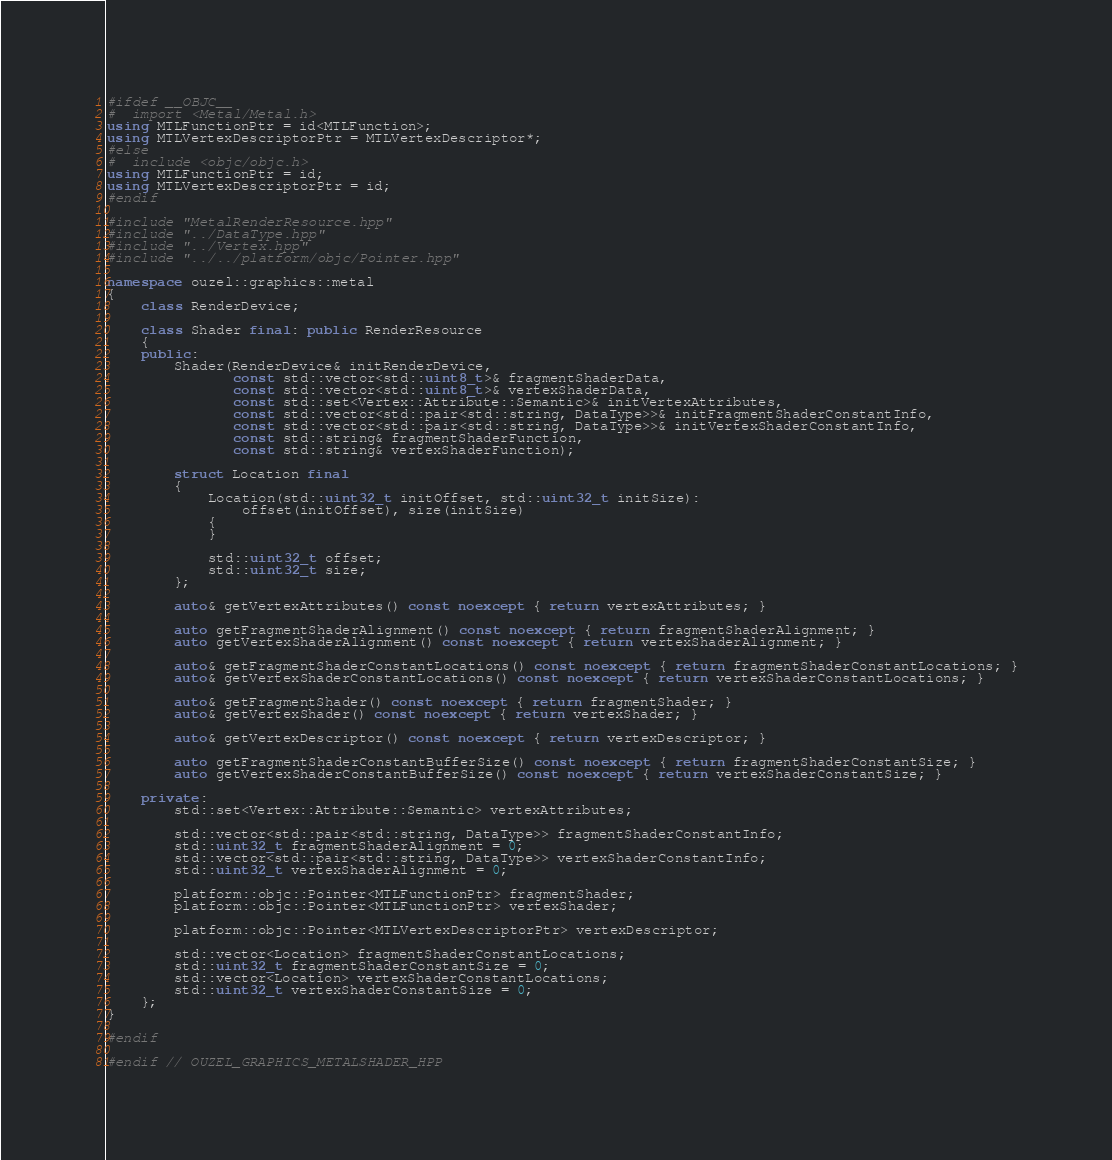<code> <loc_0><loc_0><loc_500><loc_500><_C++_>
#ifdef __OBJC__
#  import <Metal/Metal.h>
using MTLFunctionPtr = id<MTLFunction>;
using MTLVertexDescriptorPtr = MTLVertexDescriptor*;
#else
#  include <objc/objc.h>
using MTLFunctionPtr = id;
using MTLVertexDescriptorPtr = id;
#endif

#include "MetalRenderResource.hpp"
#include "../DataType.hpp"
#include "../Vertex.hpp"
#include "../../platform/objc/Pointer.hpp"

namespace ouzel::graphics::metal
{
    class RenderDevice;

    class Shader final: public RenderResource
    {
    public:
        Shader(RenderDevice& initRenderDevice,
               const std::vector<std::uint8_t>& fragmentShaderData,
               const std::vector<std::uint8_t>& vertexShaderData,
               const std::set<Vertex::Attribute::Semantic>& initVertexAttributes,
               const std::vector<std::pair<std::string, DataType>>& initFragmentShaderConstantInfo,
               const std::vector<std::pair<std::string, DataType>>& initVertexShaderConstantInfo,
               const std::string& fragmentShaderFunction,
               const std::string& vertexShaderFunction);

        struct Location final
        {
            Location(std::uint32_t initOffset, std::uint32_t initSize):
                offset(initOffset), size(initSize)
            {
            }

            std::uint32_t offset;
            std::uint32_t size;
        };

        auto& getVertexAttributes() const noexcept { return vertexAttributes; }

        auto getFragmentShaderAlignment() const noexcept { return fragmentShaderAlignment; }
        auto getVertexShaderAlignment() const noexcept { return vertexShaderAlignment; }

        auto& getFragmentShaderConstantLocations() const noexcept { return fragmentShaderConstantLocations; }
        auto& getVertexShaderConstantLocations() const noexcept { return vertexShaderConstantLocations; }

        auto& getFragmentShader() const noexcept { return fragmentShader; }
        auto& getVertexShader() const noexcept { return vertexShader; }

        auto& getVertexDescriptor() const noexcept { return vertexDescriptor; }

        auto getFragmentShaderConstantBufferSize() const noexcept { return fragmentShaderConstantSize; }
        auto getVertexShaderConstantBufferSize() const noexcept { return vertexShaderConstantSize; }

    private:
        std::set<Vertex::Attribute::Semantic> vertexAttributes;

        std::vector<std::pair<std::string, DataType>> fragmentShaderConstantInfo;
        std::uint32_t fragmentShaderAlignment = 0;
        std::vector<std::pair<std::string, DataType>> vertexShaderConstantInfo;
        std::uint32_t vertexShaderAlignment = 0;

        platform::objc::Pointer<MTLFunctionPtr> fragmentShader;
        platform::objc::Pointer<MTLFunctionPtr> vertexShader;

        platform::objc::Pointer<MTLVertexDescriptorPtr> vertexDescriptor;

        std::vector<Location> fragmentShaderConstantLocations;
        std::uint32_t fragmentShaderConstantSize = 0;
        std::vector<Location> vertexShaderConstantLocations;
        std::uint32_t vertexShaderConstantSize = 0;
    };
}

#endif

#endif // OUZEL_GRAPHICS_METALSHADER_HPP
</code> 